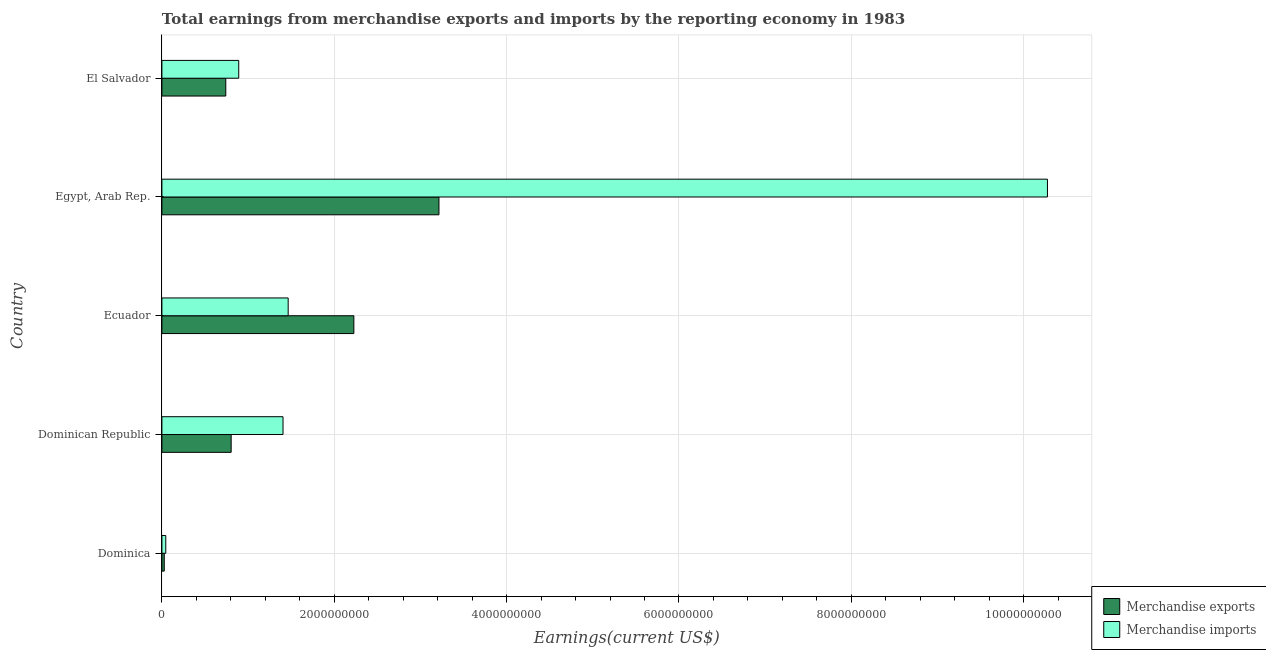Are the number of bars per tick equal to the number of legend labels?
Your answer should be very brief. Yes. Are the number of bars on each tick of the Y-axis equal?
Provide a succinct answer. Yes. How many bars are there on the 5th tick from the bottom?
Provide a succinct answer. 2. What is the label of the 2nd group of bars from the top?
Your answer should be very brief. Egypt, Arab Rep. What is the earnings from merchandise exports in Dominican Republic?
Give a very brief answer. 8.04e+08. Across all countries, what is the maximum earnings from merchandise imports?
Your answer should be very brief. 1.03e+1. Across all countries, what is the minimum earnings from merchandise imports?
Provide a short and direct response. 4.51e+07. In which country was the earnings from merchandise exports maximum?
Make the answer very short. Egypt, Arab Rep. In which country was the earnings from merchandise exports minimum?
Keep it short and to the point. Dominica. What is the total earnings from merchandise exports in the graph?
Provide a succinct answer. 7.01e+09. What is the difference between the earnings from merchandise exports in Dominican Republic and that in Egypt, Arab Rep.?
Offer a terse response. -2.41e+09. What is the difference between the earnings from merchandise imports in Egypt, Arab Rep. and the earnings from merchandise exports in Dominica?
Your response must be concise. 1.02e+1. What is the average earnings from merchandise imports per country?
Your response must be concise. 2.82e+09. What is the difference between the earnings from merchandise imports and earnings from merchandise exports in Egypt, Arab Rep.?
Provide a short and direct response. 7.06e+09. In how many countries, is the earnings from merchandise imports greater than 3600000000 US$?
Provide a short and direct response. 1. What is the ratio of the earnings from merchandise exports in Dominican Republic to that in El Salvador?
Keep it short and to the point. 1.08. Is the earnings from merchandise exports in Dominica less than that in Ecuador?
Offer a very short reply. Yes. Is the difference between the earnings from merchandise imports in Dominican Republic and Egypt, Arab Rep. greater than the difference between the earnings from merchandise exports in Dominican Republic and Egypt, Arab Rep.?
Your answer should be compact. No. What is the difference between the highest and the second highest earnings from merchandise imports?
Provide a succinct answer. 8.81e+09. What is the difference between the highest and the lowest earnings from merchandise imports?
Keep it short and to the point. 1.02e+1. What does the 2nd bar from the bottom in Dominica represents?
Your response must be concise. Merchandise imports. Does the graph contain any zero values?
Provide a succinct answer. No. Does the graph contain grids?
Offer a very short reply. Yes. How are the legend labels stacked?
Make the answer very short. Vertical. What is the title of the graph?
Offer a terse response. Total earnings from merchandise exports and imports by the reporting economy in 1983. What is the label or title of the X-axis?
Keep it short and to the point. Earnings(current US$). What is the Earnings(current US$) of Merchandise exports in Dominica?
Offer a very short reply. 2.75e+07. What is the Earnings(current US$) of Merchandise imports in Dominica?
Provide a short and direct response. 4.51e+07. What is the Earnings(current US$) in Merchandise exports in Dominican Republic?
Offer a very short reply. 8.04e+08. What is the Earnings(current US$) in Merchandise imports in Dominican Republic?
Provide a short and direct response. 1.41e+09. What is the Earnings(current US$) in Merchandise exports in Ecuador?
Your response must be concise. 2.23e+09. What is the Earnings(current US$) in Merchandise imports in Ecuador?
Ensure brevity in your answer.  1.47e+09. What is the Earnings(current US$) in Merchandise exports in Egypt, Arab Rep.?
Provide a short and direct response. 3.21e+09. What is the Earnings(current US$) in Merchandise imports in Egypt, Arab Rep.?
Give a very brief answer. 1.03e+1. What is the Earnings(current US$) in Merchandise exports in El Salvador?
Offer a terse response. 7.41e+08. What is the Earnings(current US$) in Merchandise imports in El Salvador?
Ensure brevity in your answer.  8.92e+08. Across all countries, what is the maximum Earnings(current US$) in Merchandise exports?
Give a very brief answer. 3.21e+09. Across all countries, what is the maximum Earnings(current US$) in Merchandise imports?
Your response must be concise. 1.03e+1. Across all countries, what is the minimum Earnings(current US$) of Merchandise exports?
Offer a very short reply. 2.75e+07. Across all countries, what is the minimum Earnings(current US$) in Merchandise imports?
Your answer should be very brief. 4.51e+07. What is the total Earnings(current US$) of Merchandise exports in the graph?
Ensure brevity in your answer.  7.01e+09. What is the total Earnings(current US$) of Merchandise imports in the graph?
Keep it short and to the point. 1.41e+1. What is the difference between the Earnings(current US$) of Merchandise exports in Dominica and that in Dominican Republic?
Provide a succinct answer. -7.76e+08. What is the difference between the Earnings(current US$) of Merchandise imports in Dominica and that in Dominican Republic?
Offer a very short reply. -1.36e+09. What is the difference between the Earnings(current US$) of Merchandise exports in Dominica and that in Ecuador?
Your answer should be compact. -2.20e+09. What is the difference between the Earnings(current US$) in Merchandise imports in Dominica and that in Ecuador?
Make the answer very short. -1.42e+09. What is the difference between the Earnings(current US$) of Merchandise exports in Dominica and that in Egypt, Arab Rep.?
Give a very brief answer. -3.19e+09. What is the difference between the Earnings(current US$) in Merchandise imports in Dominica and that in Egypt, Arab Rep.?
Offer a very short reply. -1.02e+1. What is the difference between the Earnings(current US$) of Merchandise exports in Dominica and that in El Salvador?
Ensure brevity in your answer.  -7.14e+08. What is the difference between the Earnings(current US$) of Merchandise imports in Dominica and that in El Salvador?
Your response must be concise. -8.46e+08. What is the difference between the Earnings(current US$) of Merchandise exports in Dominican Republic and that in Ecuador?
Your response must be concise. -1.42e+09. What is the difference between the Earnings(current US$) in Merchandise imports in Dominican Republic and that in Ecuador?
Make the answer very short. -5.97e+07. What is the difference between the Earnings(current US$) of Merchandise exports in Dominican Republic and that in Egypt, Arab Rep.?
Your answer should be compact. -2.41e+09. What is the difference between the Earnings(current US$) of Merchandise imports in Dominican Republic and that in Egypt, Arab Rep.?
Your answer should be compact. -8.87e+09. What is the difference between the Earnings(current US$) in Merchandise exports in Dominican Republic and that in El Salvador?
Offer a very short reply. 6.23e+07. What is the difference between the Earnings(current US$) of Merchandise imports in Dominican Republic and that in El Salvador?
Give a very brief answer. 5.14e+08. What is the difference between the Earnings(current US$) in Merchandise exports in Ecuador and that in Egypt, Arab Rep.?
Give a very brief answer. -9.87e+08. What is the difference between the Earnings(current US$) of Merchandise imports in Ecuador and that in Egypt, Arab Rep.?
Offer a very short reply. -8.81e+09. What is the difference between the Earnings(current US$) of Merchandise exports in Ecuador and that in El Salvador?
Keep it short and to the point. 1.49e+09. What is the difference between the Earnings(current US$) in Merchandise imports in Ecuador and that in El Salvador?
Your answer should be very brief. 5.74e+08. What is the difference between the Earnings(current US$) in Merchandise exports in Egypt, Arab Rep. and that in El Salvador?
Provide a short and direct response. 2.47e+09. What is the difference between the Earnings(current US$) in Merchandise imports in Egypt, Arab Rep. and that in El Salvador?
Offer a terse response. 9.38e+09. What is the difference between the Earnings(current US$) of Merchandise exports in Dominica and the Earnings(current US$) of Merchandise imports in Dominican Republic?
Provide a short and direct response. -1.38e+09. What is the difference between the Earnings(current US$) of Merchandise exports in Dominica and the Earnings(current US$) of Merchandise imports in Ecuador?
Ensure brevity in your answer.  -1.44e+09. What is the difference between the Earnings(current US$) in Merchandise exports in Dominica and the Earnings(current US$) in Merchandise imports in Egypt, Arab Rep.?
Provide a succinct answer. -1.02e+1. What is the difference between the Earnings(current US$) in Merchandise exports in Dominica and the Earnings(current US$) in Merchandise imports in El Salvador?
Offer a terse response. -8.64e+08. What is the difference between the Earnings(current US$) in Merchandise exports in Dominican Republic and the Earnings(current US$) in Merchandise imports in Ecuador?
Offer a very short reply. -6.62e+08. What is the difference between the Earnings(current US$) in Merchandise exports in Dominican Republic and the Earnings(current US$) in Merchandise imports in Egypt, Arab Rep.?
Ensure brevity in your answer.  -9.47e+09. What is the difference between the Earnings(current US$) in Merchandise exports in Dominican Republic and the Earnings(current US$) in Merchandise imports in El Salvador?
Ensure brevity in your answer.  -8.79e+07. What is the difference between the Earnings(current US$) in Merchandise exports in Ecuador and the Earnings(current US$) in Merchandise imports in Egypt, Arab Rep.?
Provide a short and direct response. -8.05e+09. What is the difference between the Earnings(current US$) in Merchandise exports in Ecuador and the Earnings(current US$) in Merchandise imports in El Salvador?
Provide a short and direct response. 1.34e+09. What is the difference between the Earnings(current US$) in Merchandise exports in Egypt, Arab Rep. and the Earnings(current US$) in Merchandise imports in El Salvador?
Offer a very short reply. 2.32e+09. What is the average Earnings(current US$) in Merchandise exports per country?
Ensure brevity in your answer.  1.40e+09. What is the average Earnings(current US$) in Merchandise imports per country?
Your response must be concise. 2.82e+09. What is the difference between the Earnings(current US$) in Merchandise exports and Earnings(current US$) in Merchandise imports in Dominica?
Ensure brevity in your answer.  -1.76e+07. What is the difference between the Earnings(current US$) in Merchandise exports and Earnings(current US$) in Merchandise imports in Dominican Republic?
Your answer should be very brief. -6.02e+08. What is the difference between the Earnings(current US$) of Merchandise exports and Earnings(current US$) of Merchandise imports in Ecuador?
Your answer should be compact. 7.62e+08. What is the difference between the Earnings(current US$) in Merchandise exports and Earnings(current US$) in Merchandise imports in Egypt, Arab Rep.?
Offer a terse response. -7.06e+09. What is the difference between the Earnings(current US$) of Merchandise exports and Earnings(current US$) of Merchandise imports in El Salvador?
Ensure brevity in your answer.  -1.50e+08. What is the ratio of the Earnings(current US$) of Merchandise exports in Dominica to that in Dominican Republic?
Your answer should be very brief. 0.03. What is the ratio of the Earnings(current US$) of Merchandise imports in Dominica to that in Dominican Republic?
Offer a very short reply. 0.03. What is the ratio of the Earnings(current US$) of Merchandise exports in Dominica to that in Ecuador?
Give a very brief answer. 0.01. What is the ratio of the Earnings(current US$) of Merchandise imports in Dominica to that in Ecuador?
Keep it short and to the point. 0.03. What is the ratio of the Earnings(current US$) of Merchandise exports in Dominica to that in Egypt, Arab Rep.?
Make the answer very short. 0.01. What is the ratio of the Earnings(current US$) of Merchandise imports in Dominica to that in Egypt, Arab Rep.?
Ensure brevity in your answer.  0. What is the ratio of the Earnings(current US$) in Merchandise exports in Dominica to that in El Salvador?
Give a very brief answer. 0.04. What is the ratio of the Earnings(current US$) of Merchandise imports in Dominica to that in El Salvador?
Keep it short and to the point. 0.05. What is the ratio of the Earnings(current US$) in Merchandise exports in Dominican Republic to that in Ecuador?
Give a very brief answer. 0.36. What is the ratio of the Earnings(current US$) of Merchandise imports in Dominican Republic to that in Ecuador?
Provide a succinct answer. 0.96. What is the ratio of the Earnings(current US$) of Merchandise imports in Dominican Republic to that in Egypt, Arab Rep.?
Your answer should be compact. 0.14. What is the ratio of the Earnings(current US$) in Merchandise exports in Dominican Republic to that in El Salvador?
Your answer should be compact. 1.08. What is the ratio of the Earnings(current US$) of Merchandise imports in Dominican Republic to that in El Salvador?
Your response must be concise. 1.58. What is the ratio of the Earnings(current US$) of Merchandise exports in Ecuador to that in Egypt, Arab Rep.?
Offer a very short reply. 0.69. What is the ratio of the Earnings(current US$) in Merchandise imports in Ecuador to that in Egypt, Arab Rep.?
Give a very brief answer. 0.14. What is the ratio of the Earnings(current US$) of Merchandise exports in Ecuador to that in El Salvador?
Your answer should be compact. 3. What is the ratio of the Earnings(current US$) in Merchandise imports in Ecuador to that in El Salvador?
Your answer should be very brief. 1.64. What is the ratio of the Earnings(current US$) of Merchandise exports in Egypt, Arab Rep. to that in El Salvador?
Your answer should be very brief. 4.34. What is the ratio of the Earnings(current US$) of Merchandise imports in Egypt, Arab Rep. to that in El Salvador?
Keep it short and to the point. 11.53. What is the difference between the highest and the second highest Earnings(current US$) of Merchandise exports?
Keep it short and to the point. 9.87e+08. What is the difference between the highest and the second highest Earnings(current US$) in Merchandise imports?
Provide a succinct answer. 8.81e+09. What is the difference between the highest and the lowest Earnings(current US$) of Merchandise exports?
Your answer should be very brief. 3.19e+09. What is the difference between the highest and the lowest Earnings(current US$) of Merchandise imports?
Make the answer very short. 1.02e+1. 